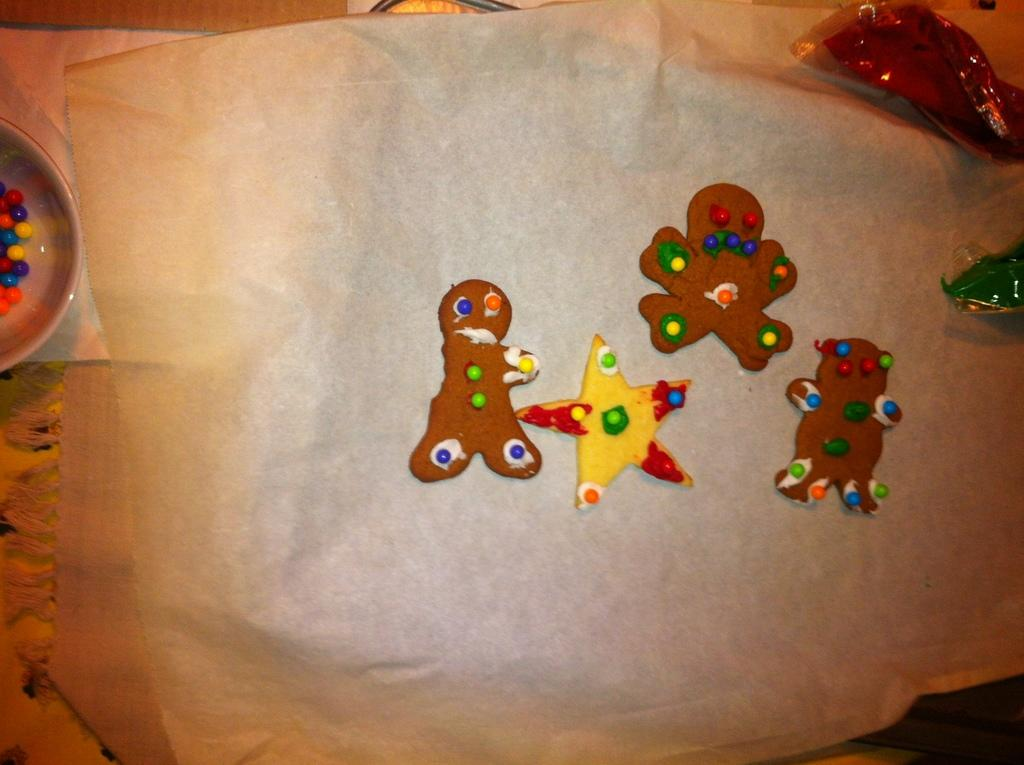What is depicted on the cloth in the image? There is a painting on a cloth in the image. What is inside the bowl that is visible in the image? There is a bowl with colored balls in the image. What item might be used for cleaning or wiping in the image? There is a napkin in the image. How many legs can be seen on the painting in the image? There are no legs visible in the image, as it features a painting on a cloth and not a living creature. 